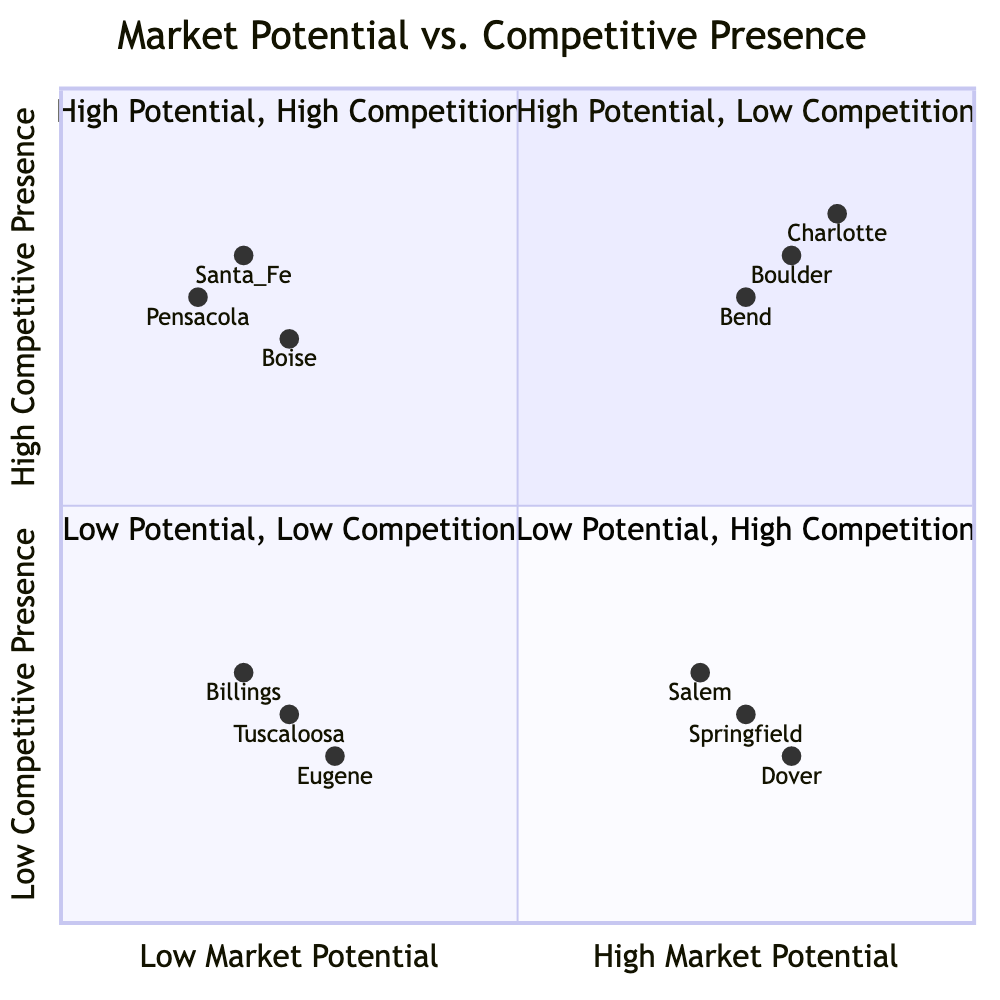What are the organizations in the "High Potential, Low Competition" quadrant? The "High Potential, Low Competition" quadrant includes Springfield, Dover, and Salem as the organizations. This can be determined by looking specifically at the quadrant labeled accordingly in the chart.
Answer: Springfield, Dover, Salem Which quadrant contains the most organizations? By analyzing the data, the "High Potential, High Competition" quadrant has three organizations (Charlotte, Boulder, Bend), which is more than the others.
Answer: High Potential, High Competition How many organizations are there in the "Low Potential, High Competition" quadrant? The "Low Potential, High Competition" quadrant has three organizations listed: Pensacola, Santa Fe, and Boise. Count the items from that section of the chart to find the total.
Answer: 3 Which market shows both high potential and high competition? The diagram indicates that Charlotte, Boulder, and Bend are the markets with high potential and high competition. Look for the quadrant that specifies this combination to answer.
Answer: Charlotte, Boulder, Bend What unique characteristic defines the "Low Potential, Low Competition" quadrant? This quadrant is characterized by a combination of low market potential and low competitive presence, which implies limited opportunity for growth. This definition is derived from the quadrants' labels and descriptions.
Answer: Limited opportunity for growth Which market has the lowest competitive presence? Pensacola has the lowest competitive presence indicated by its placement low on the vertical axis. To find this, observe the positions of the markets on the chart.
Answer: Pensacola 